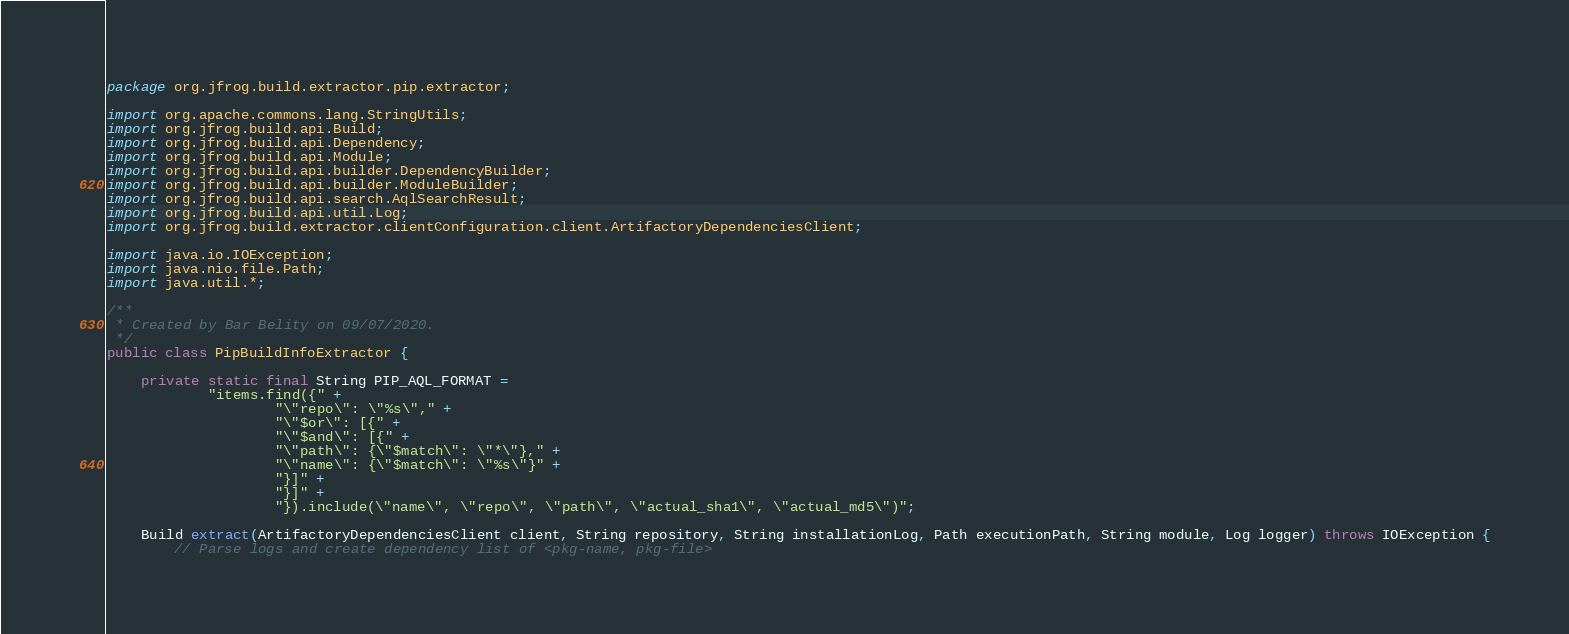<code> <loc_0><loc_0><loc_500><loc_500><_Java_>package org.jfrog.build.extractor.pip.extractor;

import org.apache.commons.lang.StringUtils;
import org.jfrog.build.api.Build;
import org.jfrog.build.api.Dependency;
import org.jfrog.build.api.Module;
import org.jfrog.build.api.builder.DependencyBuilder;
import org.jfrog.build.api.builder.ModuleBuilder;
import org.jfrog.build.api.search.AqlSearchResult;
import org.jfrog.build.api.util.Log;
import org.jfrog.build.extractor.clientConfiguration.client.ArtifactoryDependenciesClient;

import java.io.IOException;
import java.nio.file.Path;
import java.util.*;

/**
 * Created by Bar Belity on 09/07/2020.
 */
public class PipBuildInfoExtractor {

    private static final String PIP_AQL_FORMAT =
            "items.find({" +
                    "\"repo\": \"%s\"," +
                    "\"$or\": [{" +
                    "\"$and\": [{" +
                    "\"path\": {\"$match\": \"*\"}," +
                    "\"name\": {\"$match\": \"%s\"}" +
                    "}]" +
                    "}]" +
                    "}).include(\"name\", \"repo\", \"path\", \"actual_sha1\", \"actual_md5\")";

    Build extract(ArtifactoryDependenciesClient client, String repository, String installationLog, Path executionPath, String module, Log logger) throws IOException {
        // Parse logs and create dependency list of <pkg-name, pkg-file></code> 